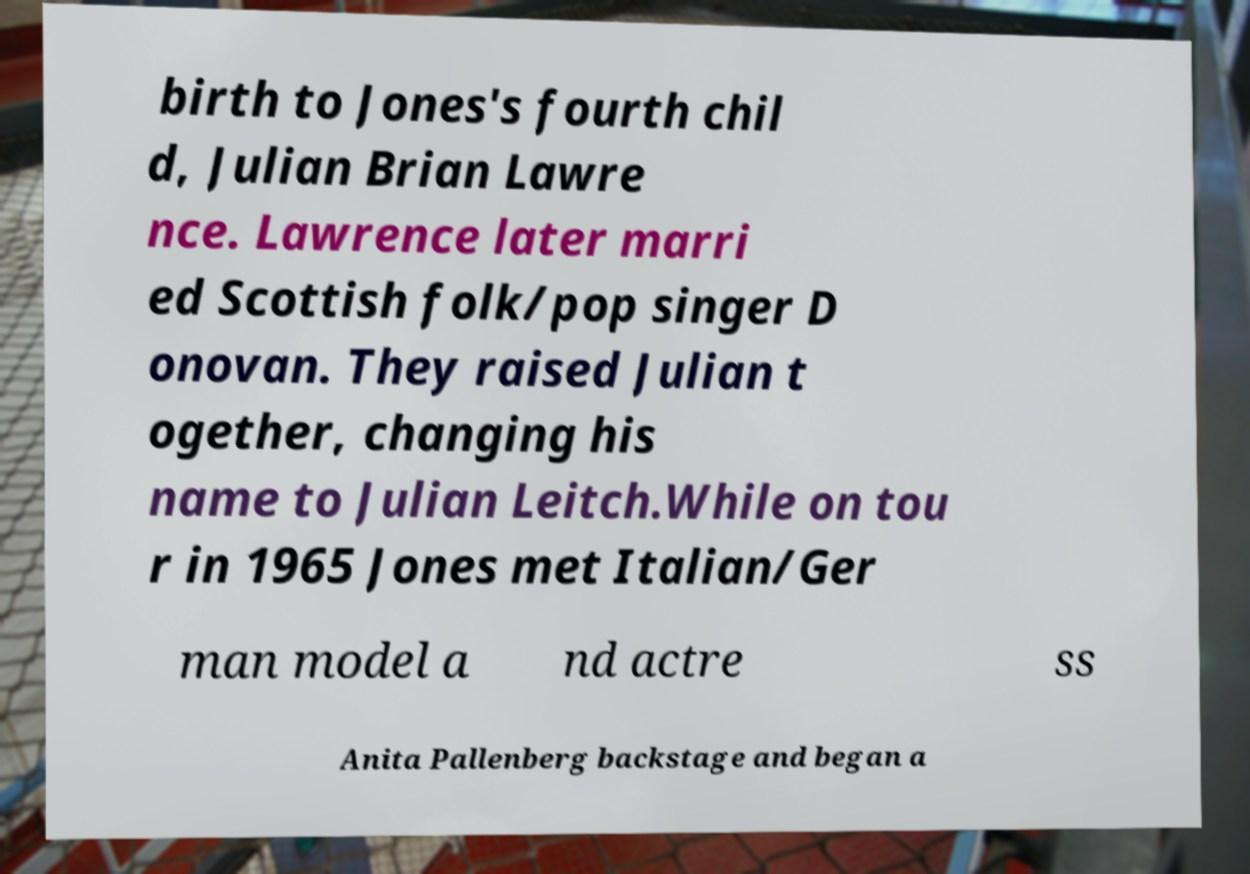There's text embedded in this image that I need extracted. Can you transcribe it verbatim? birth to Jones's fourth chil d, Julian Brian Lawre nce. Lawrence later marri ed Scottish folk/pop singer D onovan. They raised Julian t ogether, changing his name to Julian Leitch.While on tou r in 1965 Jones met Italian/Ger man model a nd actre ss Anita Pallenberg backstage and began a 